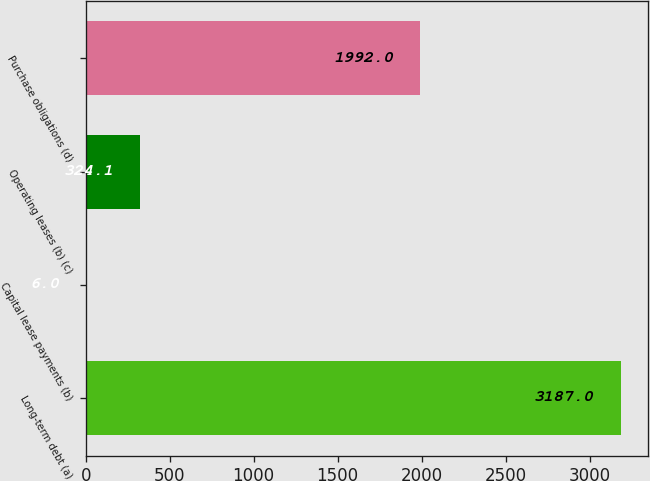Convert chart. <chart><loc_0><loc_0><loc_500><loc_500><bar_chart><fcel>Long-term debt (a)<fcel>Capital lease payments (b)<fcel>Operating leases (b) (c)<fcel>Purchase obligations (d)<nl><fcel>3187<fcel>6<fcel>324.1<fcel>1992<nl></chart> 